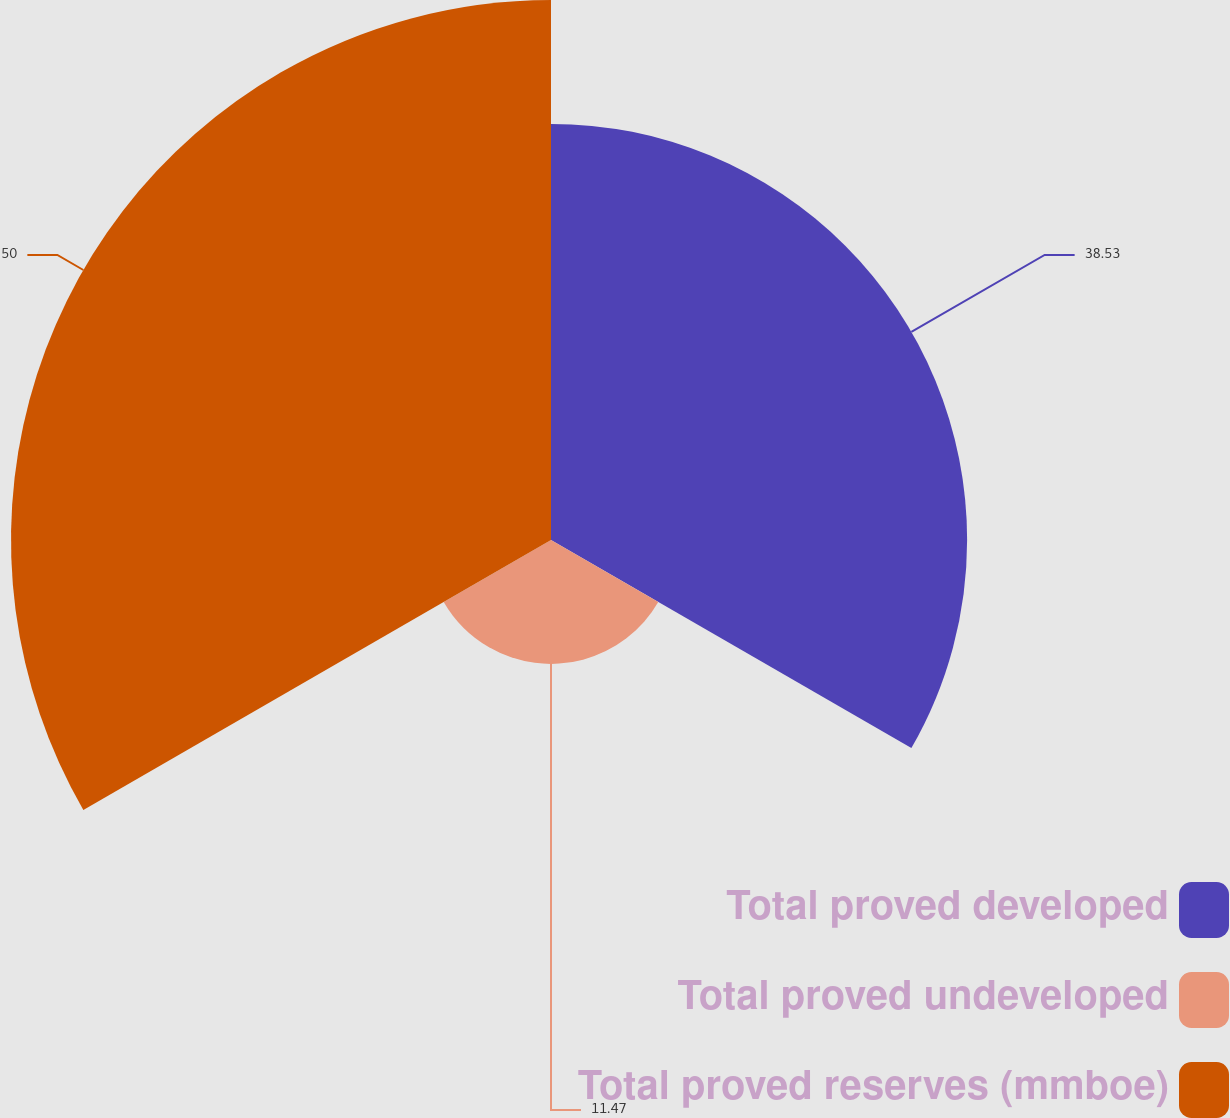Convert chart. <chart><loc_0><loc_0><loc_500><loc_500><pie_chart><fcel>Total proved developed<fcel>Total proved undeveloped<fcel>Total proved reserves (mmboe)<nl><fcel>38.53%<fcel>11.47%<fcel>50.0%<nl></chart> 